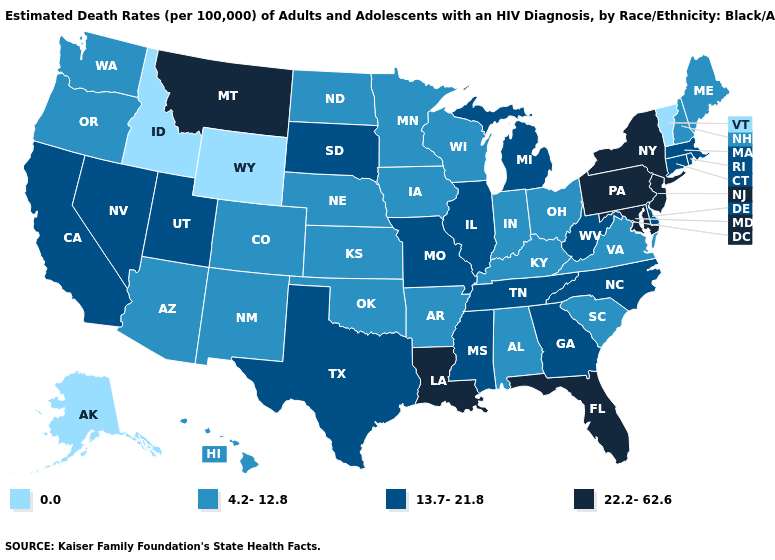What is the lowest value in states that border West Virginia?
Keep it brief. 4.2-12.8. Does New York have the highest value in the USA?
Give a very brief answer. Yes. What is the highest value in the USA?
Write a very short answer. 22.2-62.6. What is the lowest value in states that border Iowa?
Answer briefly. 4.2-12.8. Does Connecticut have the same value as Mississippi?
Quick response, please. Yes. What is the value of Idaho?
Be succinct. 0.0. Name the states that have a value in the range 4.2-12.8?
Quick response, please. Alabama, Arizona, Arkansas, Colorado, Hawaii, Indiana, Iowa, Kansas, Kentucky, Maine, Minnesota, Nebraska, New Hampshire, New Mexico, North Dakota, Ohio, Oklahoma, Oregon, South Carolina, Virginia, Washington, Wisconsin. Does Virginia have the same value as Michigan?
Write a very short answer. No. What is the value of Iowa?
Give a very brief answer. 4.2-12.8. Name the states that have a value in the range 22.2-62.6?
Quick response, please. Florida, Louisiana, Maryland, Montana, New Jersey, New York, Pennsylvania. Which states have the lowest value in the Northeast?
Short answer required. Vermont. What is the lowest value in the USA?
Concise answer only. 0.0. Which states hav the highest value in the Northeast?
Quick response, please. New Jersey, New York, Pennsylvania. Is the legend a continuous bar?
Be succinct. No. What is the value of Missouri?
Quick response, please. 13.7-21.8. 